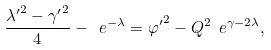Convert formula to latex. <formula><loc_0><loc_0><loc_500><loc_500>\frac { { \lambda ^ { \prime } } ^ { 2 } - { \gamma ^ { \prime } } ^ { 2 } } { 4 } - \ e ^ { - \lambda } = { \varphi ^ { \prime } } ^ { 2 } - Q ^ { 2 } \ e ^ { \gamma - 2 \lambda } ,</formula> 